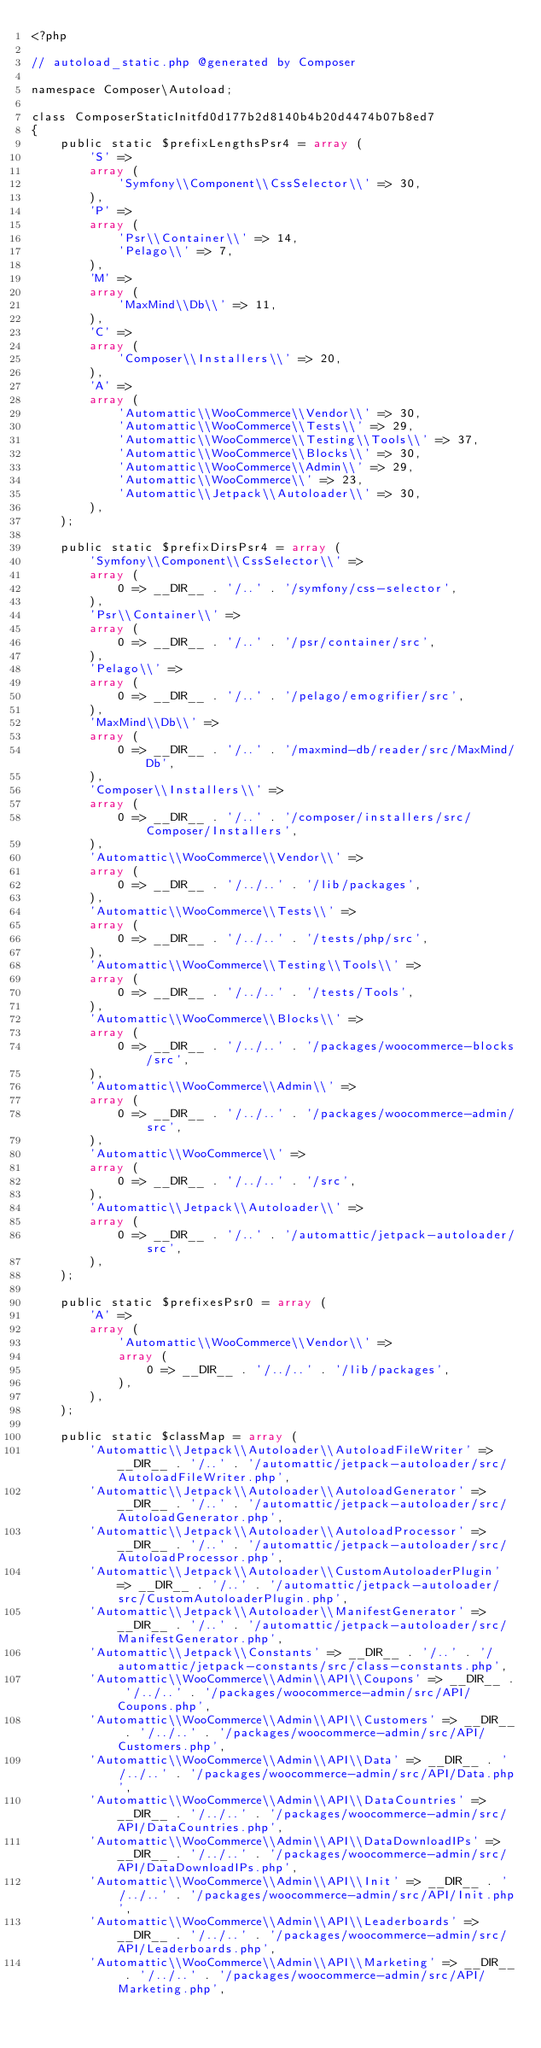Convert code to text. <code><loc_0><loc_0><loc_500><loc_500><_PHP_><?php

// autoload_static.php @generated by Composer

namespace Composer\Autoload;

class ComposerStaticInitfd0d177b2d8140b4b20d4474b07b8ed7
{
    public static $prefixLengthsPsr4 = array (
        'S' => 
        array (
            'Symfony\\Component\\CssSelector\\' => 30,
        ),
        'P' => 
        array (
            'Psr\\Container\\' => 14,
            'Pelago\\' => 7,
        ),
        'M' => 
        array (
            'MaxMind\\Db\\' => 11,
        ),
        'C' => 
        array (
            'Composer\\Installers\\' => 20,
        ),
        'A' => 
        array (
            'Automattic\\WooCommerce\\Vendor\\' => 30,
            'Automattic\\WooCommerce\\Tests\\' => 29,
            'Automattic\\WooCommerce\\Testing\\Tools\\' => 37,
            'Automattic\\WooCommerce\\Blocks\\' => 30,
            'Automattic\\WooCommerce\\Admin\\' => 29,
            'Automattic\\WooCommerce\\' => 23,
            'Automattic\\Jetpack\\Autoloader\\' => 30,
        ),
    );

    public static $prefixDirsPsr4 = array (
        'Symfony\\Component\\CssSelector\\' => 
        array (
            0 => __DIR__ . '/..' . '/symfony/css-selector',
        ),
        'Psr\\Container\\' => 
        array (
            0 => __DIR__ . '/..' . '/psr/container/src',
        ),
        'Pelago\\' => 
        array (
            0 => __DIR__ . '/..' . '/pelago/emogrifier/src',
        ),
        'MaxMind\\Db\\' => 
        array (
            0 => __DIR__ . '/..' . '/maxmind-db/reader/src/MaxMind/Db',
        ),
        'Composer\\Installers\\' => 
        array (
            0 => __DIR__ . '/..' . '/composer/installers/src/Composer/Installers',
        ),
        'Automattic\\WooCommerce\\Vendor\\' => 
        array (
            0 => __DIR__ . '/../..' . '/lib/packages',
        ),
        'Automattic\\WooCommerce\\Tests\\' => 
        array (
            0 => __DIR__ . '/../..' . '/tests/php/src',
        ),
        'Automattic\\WooCommerce\\Testing\\Tools\\' => 
        array (
            0 => __DIR__ . '/../..' . '/tests/Tools',
        ),
        'Automattic\\WooCommerce\\Blocks\\' => 
        array (
            0 => __DIR__ . '/../..' . '/packages/woocommerce-blocks/src',
        ),
        'Automattic\\WooCommerce\\Admin\\' => 
        array (
            0 => __DIR__ . '/../..' . '/packages/woocommerce-admin/src',
        ),
        'Automattic\\WooCommerce\\' => 
        array (
            0 => __DIR__ . '/../..' . '/src',
        ),
        'Automattic\\Jetpack\\Autoloader\\' => 
        array (
            0 => __DIR__ . '/..' . '/automattic/jetpack-autoloader/src',
        ),
    );

    public static $prefixesPsr0 = array (
        'A' => 
        array (
            'Automattic\\WooCommerce\\Vendor\\' => 
            array (
                0 => __DIR__ . '/../..' . '/lib/packages',
            ),
        ),
    );

    public static $classMap = array (
        'Automattic\\Jetpack\\Autoloader\\AutoloadFileWriter' => __DIR__ . '/..' . '/automattic/jetpack-autoloader/src/AutoloadFileWriter.php',
        'Automattic\\Jetpack\\Autoloader\\AutoloadGenerator' => __DIR__ . '/..' . '/automattic/jetpack-autoloader/src/AutoloadGenerator.php',
        'Automattic\\Jetpack\\Autoloader\\AutoloadProcessor' => __DIR__ . '/..' . '/automattic/jetpack-autoloader/src/AutoloadProcessor.php',
        'Automattic\\Jetpack\\Autoloader\\CustomAutoloaderPlugin' => __DIR__ . '/..' . '/automattic/jetpack-autoloader/src/CustomAutoloaderPlugin.php',
        'Automattic\\Jetpack\\Autoloader\\ManifestGenerator' => __DIR__ . '/..' . '/automattic/jetpack-autoloader/src/ManifestGenerator.php',
        'Automattic\\Jetpack\\Constants' => __DIR__ . '/..' . '/automattic/jetpack-constants/src/class-constants.php',
        'Automattic\\WooCommerce\\Admin\\API\\Coupons' => __DIR__ . '/../..' . '/packages/woocommerce-admin/src/API/Coupons.php',
        'Automattic\\WooCommerce\\Admin\\API\\Customers' => __DIR__ . '/../..' . '/packages/woocommerce-admin/src/API/Customers.php',
        'Automattic\\WooCommerce\\Admin\\API\\Data' => __DIR__ . '/../..' . '/packages/woocommerce-admin/src/API/Data.php',
        'Automattic\\WooCommerce\\Admin\\API\\DataCountries' => __DIR__ . '/../..' . '/packages/woocommerce-admin/src/API/DataCountries.php',
        'Automattic\\WooCommerce\\Admin\\API\\DataDownloadIPs' => __DIR__ . '/../..' . '/packages/woocommerce-admin/src/API/DataDownloadIPs.php',
        'Automattic\\WooCommerce\\Admin\\API\\Init' => __DIR__ . '/../..' . '/packages/woocommerce-admin/src/API/Init.php',
        'Automattic\\WooCommerce\\Admin\\API\\Leaderboards' => __DIR__ . '/../..' . '/packages/woocommerce-admin/src/API/Leaderboards.php',
        'Automattic\\WooCommerce\\Admin\\API\\Marketing' => __DIR__ . '/../..' . '/packages/woocommerce-admin/src/API/Marketing.php',</code> 